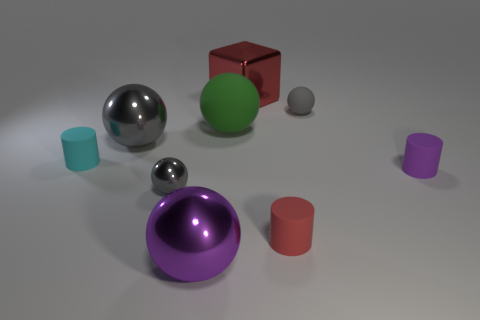Are there an equal number of metal objects to the left of the tiny cyan cylinder and large gray balls?
Make the answer very short. No. There is a matte cylinder that is to the left of the large red thing; are there any large red objects that are on the right side of it?
Offer a terse response. Yes. There is a metal object that is behind the gray ball that is to the left of the gray ball in front of the big gray metal thing; how big is it?
Your answer should be very brief. Large. What is the material of the gray object on the right side of the red thing behind the small cyan cylinder?
Offer a terse response. Rubber. Is there a small gray matte thing of the same shape as the small red rubber object?
Provide a succinct answer. No. What is the shape of the big gray metallic thing?
Offer a very short reply. Sphere. What material is the tiny cylinder that is on the left side of the gray shiny object that is behind the rubber cylinder that is left of the small shiny sphere?
Offer a very short reply. Rubber. Are there more big red metallic blocks that are right of the large gray shiny object than gray cylinders?
Offer a terse response. Yes. What is the material of the cyan cylinder that is the same size as the purple matte object?
Your answer should be compact. Rubber. Are there any green things of the same size as the purple shiny ball?
Offer a very short reply. Yes. 